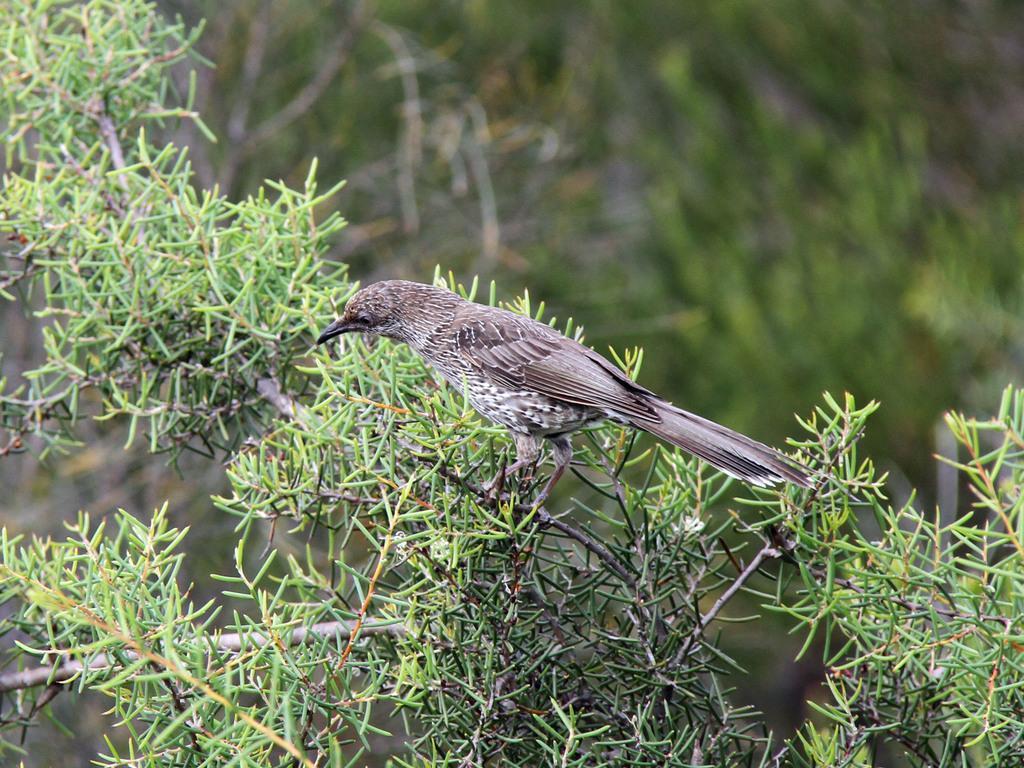How would you summarize this image in a sentence or two? This image consists of a bird on a tree. In the background, there are plants and the background is blurred. 